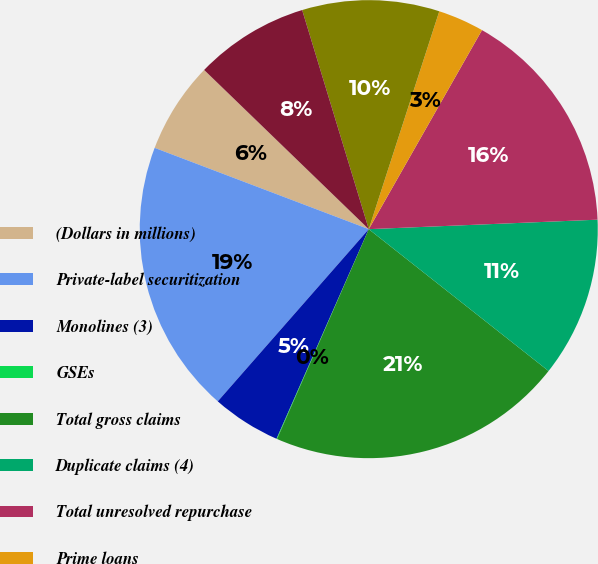<chart> <loc_0><loc_0><loc_500><loc_500><pie_chart><fcel>(Dollars in millions)<fcel>Private-label securitization<fcel>Monolines (3)<fcel>GSEs<fcel>Total gross claims<fcel>Duplicate claims (4)<fcel>Total unresolved repurchase<fcel>Prime loans<fcel>Alt-A<fcel>Home equity<nl><fcel>6.46%<fcel>19.32%<fcel>4.86%<fcel>0.04%<fcel>20.93%<fcel>11.29%<fcel>16.11%<fcel>3.25%<fcel>9.68%<fcel>8.07%<nl></chart> 